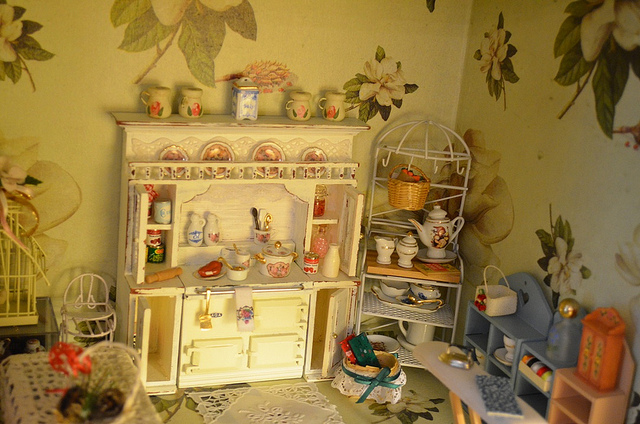How many people are in the picture? 0 